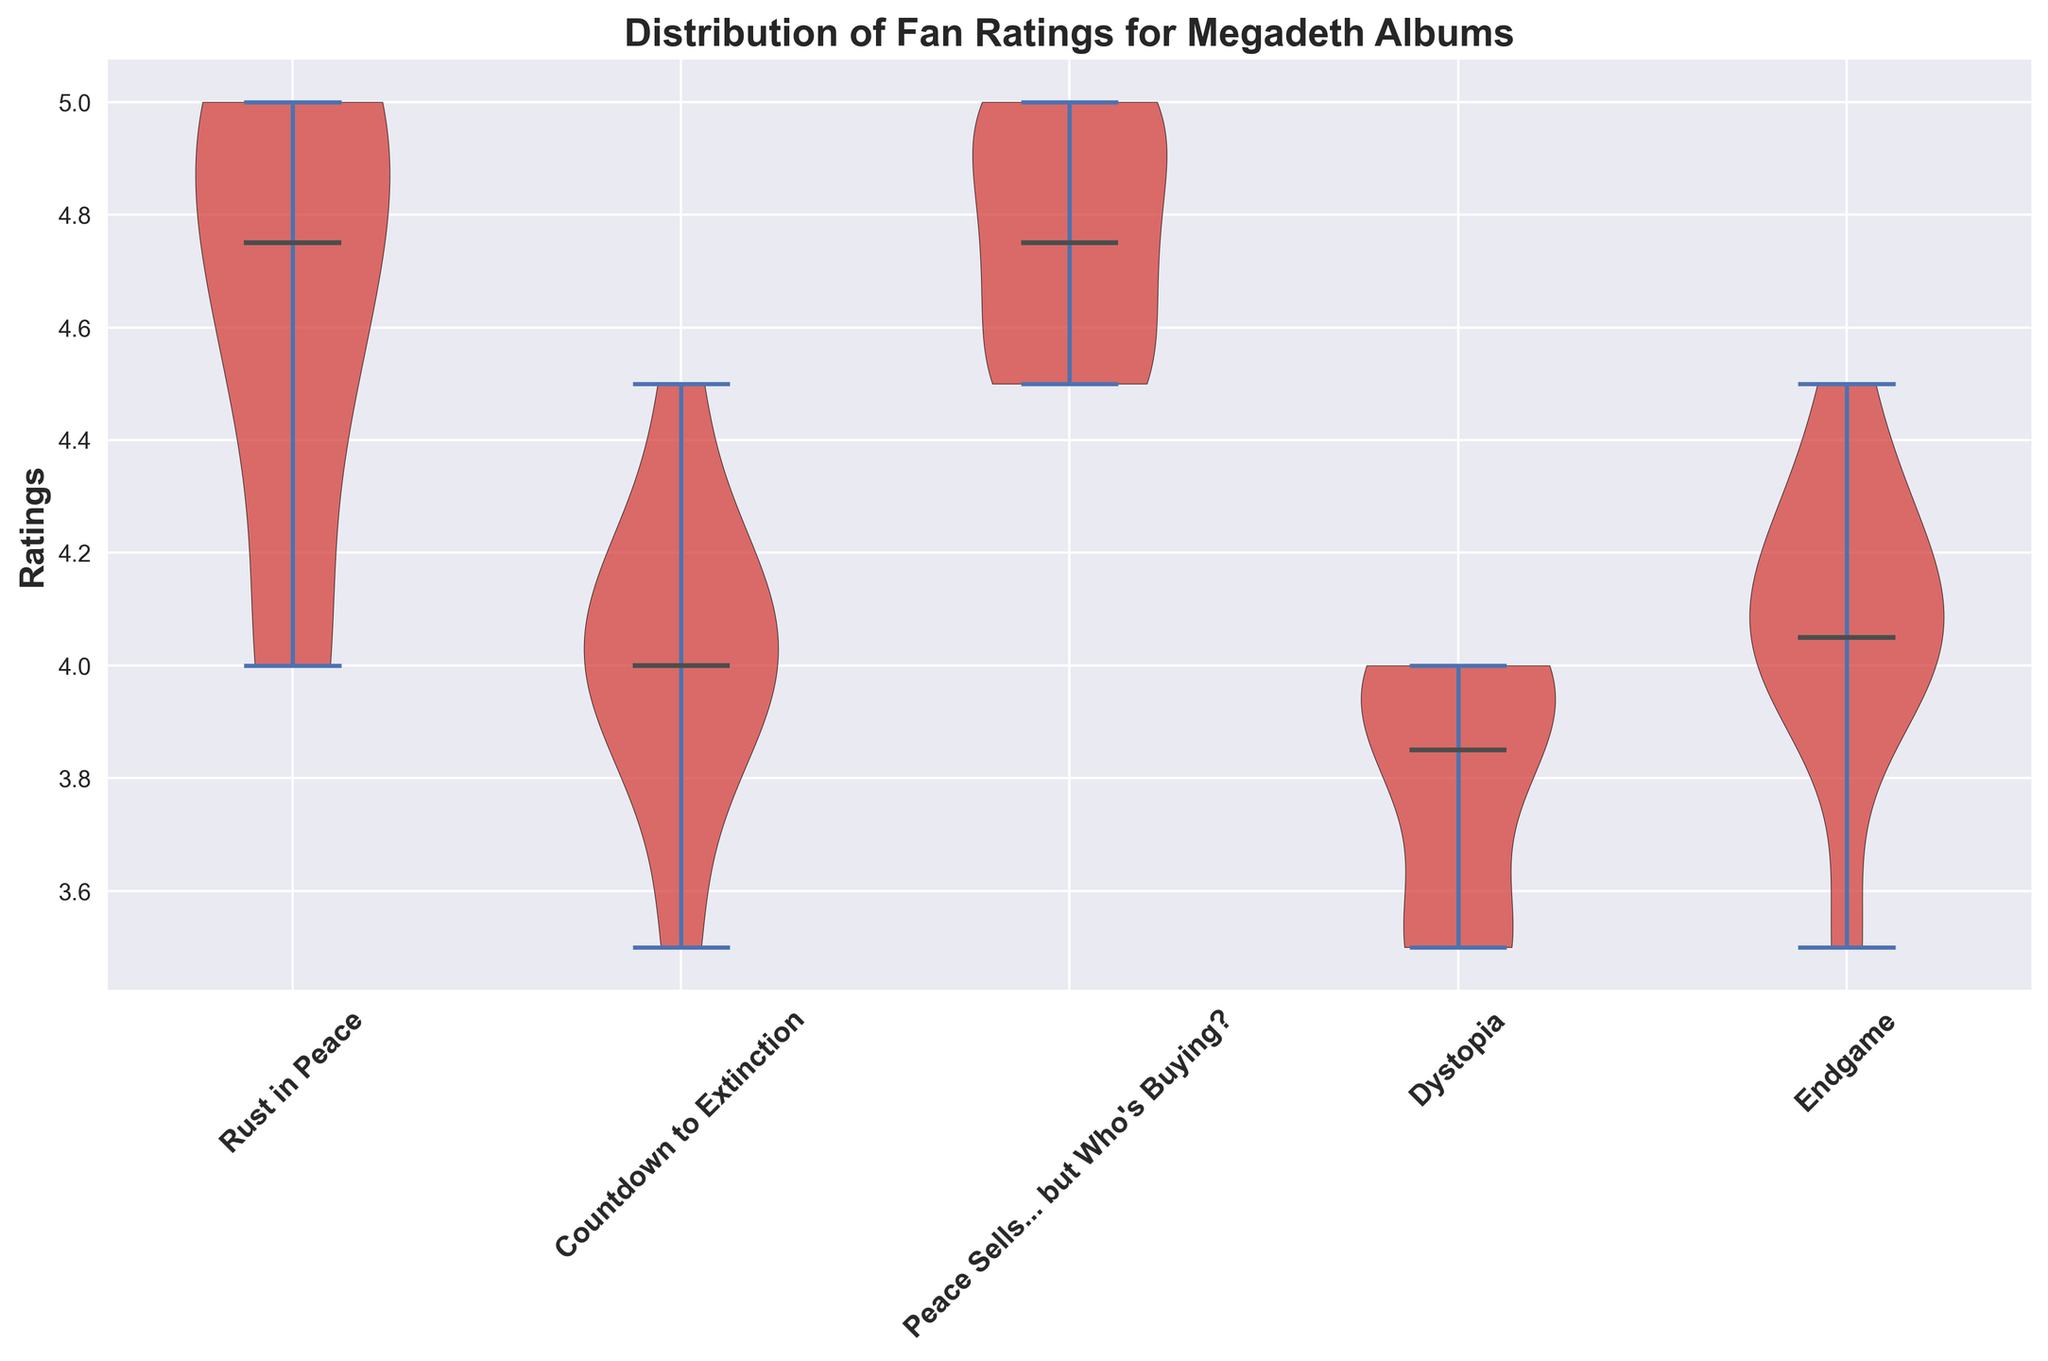Which Megadeth album has the widest distribution of fan ratings? By looking at the spread of each album's violin plot, the widest distribution can be identified based on the shape and coverage. The wider the plot, the more varied the ratings. "Rust in Peace" has a wide distribution suggesting a larger variation in ratings.
Answer: Rust in Peace Which album has the highest median rating? Median can be identified by the bold line inside each violin plot. The highest median rating is observed in "Peace Sells... but Who's Buying?".
Answer: Peace Sells... but Who's Buying? Compare the median ratings of "Rust in Peace" and "Dystopia". Which is higher? By comparing the median lines of both albums' violin plots, it is clear that "Rust in Peace" has a higher median rating than "Dystopia".
Answer: Rust in Peace What is the approximate range of ratings for the album "Endgame"? The range of ratings can be gauged from the bottom to the top of the violin plot for "Endgame". This album ranges approximately from 3.5 to 4.5.
Answer: 3.5 to 4.5 How do the fan ratings for "Countdown to Extinction" compare to those for "Peace Sells... but Who's Buying?"? By comparing the entire spans of both violin plots, "Peace Sells... but Who's Buying?" has higher fan ratings overall than "Countdown to Extinction", as the former's plot is positioned higher on the y-axis.
Answer: Peace Sells... but Who's Buying? What can you say about the uniformity of ratings for "Dystopia"? The more uniform the ratings, the narrower the violin plot. "Dystopia" shows a spread but is narrower compared to some other albums, indicating relatively more uniform ratings.
Answer: Relatively uniform Is there an album where the median rating is exactly the maximum rating? Typically, if the median line aligns with the top of the violin plot, the median is the maximum rating. For "Peace Sells... but Who's Buying?", the median appears close to the top, but not exact. None of the plots show an exact alignment.
Answer: No Which album has the most skewed ratings, suggesting most fans either love or dislike it? Skewed ratings can be inferred from the asymmetry in the violin plot. "Rust in Peace" shows a right skew with higher concentrations of high ratings, suggesting fans mostly love it.
Answer: Rust in Peace What visually distinguishes the violin plots in the chart? Several visual attributes distinguish the violin plots: the red color, the black borders, and the bold median lines in black. The plots also vary in width and height, indicating the distribution and spread of ratings.
Answer: Color, borders, medians, width, and height 